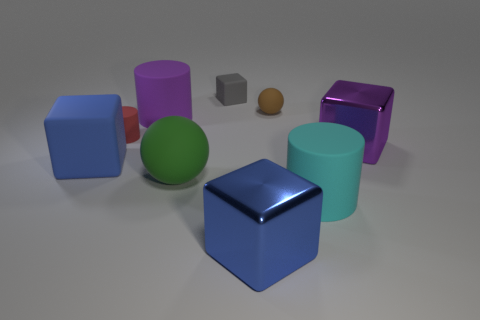How many blue cubes must be subtracted to get 1 blue cubes? 1 Add 1 large cyan objects. How many objects exist? 10 Subtract all purple cylinders. How many cylinders are left? 2 Subtract all red cylinders. How many cylinders are left? 2 Add 4 purple metal objects. How many purple metal objects are left? 5 Add 2 large blue cubes. How many large blue cubes exist? 4 Subtract 0 cyan spheres. How many objects are left? 9 Subtract all spheres. How many objects are left? 7 Subtract 1 cubes. How many cubes are left? 3 Subtract all gray spheres. Subtract all green cubes. How many spheres are left? 2 